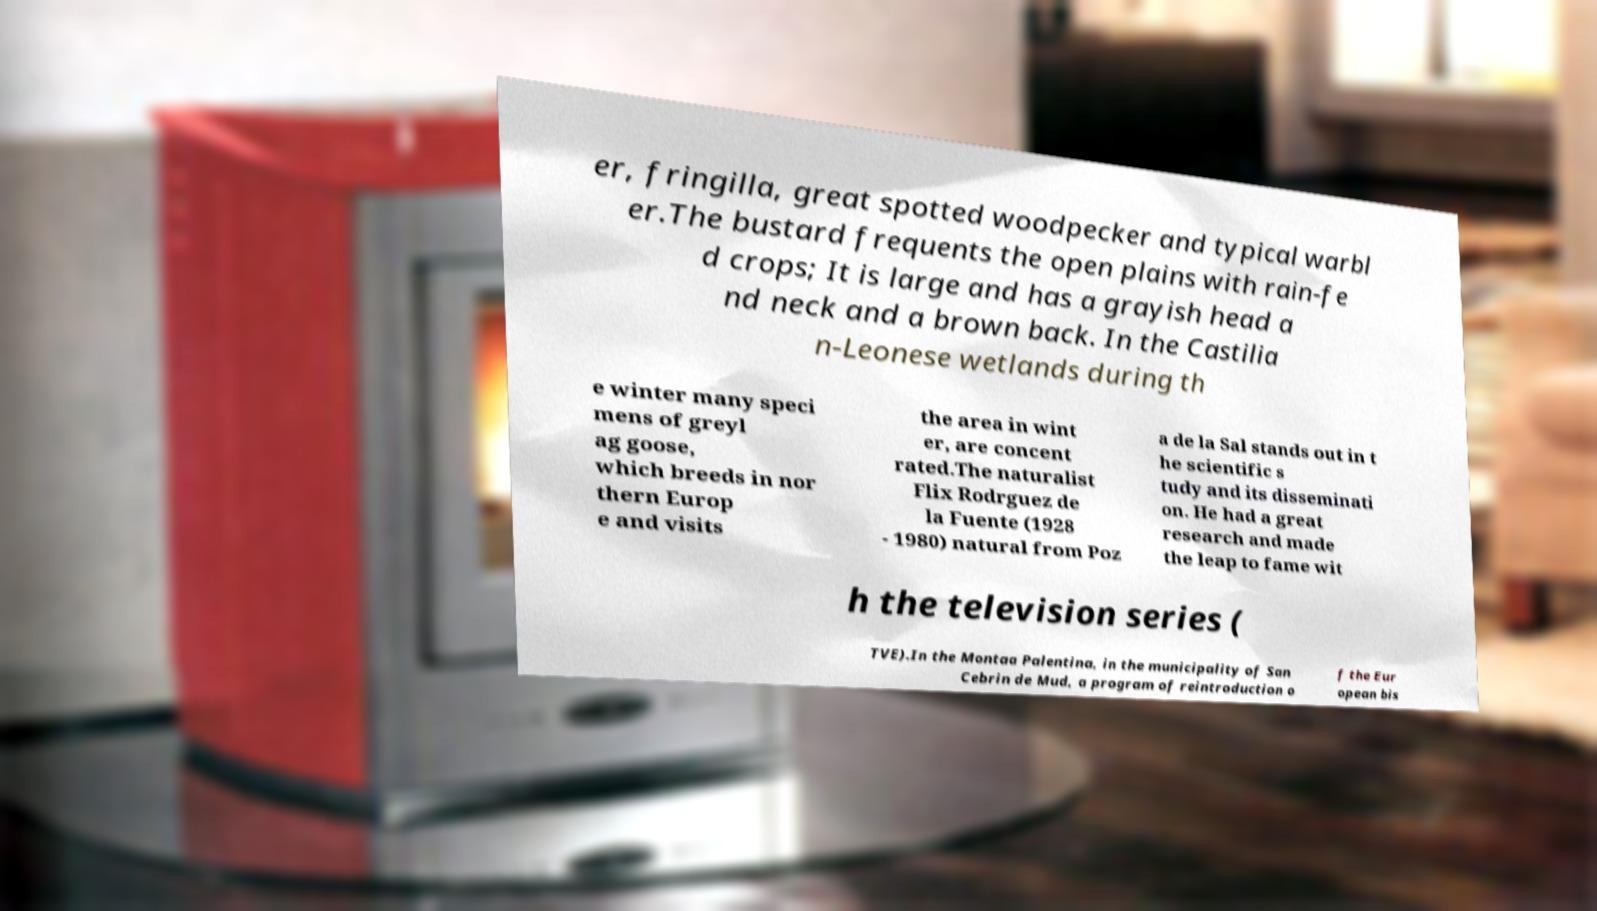Can you read and provide the text displayed in the image?This photo seems to have some interesting text. Can you extract and type it out for me? er, fringilla, great spotted woodpecker and typical warbl er.The bustard frequents the open plains with rain-fe d crops; It is large and has a grayish head a nd neck and a brown back. In the Castilia n-Leonese wetlands during th e winter many speci mens of greyl ag goose, which breeds in nor thern Europ e and visits the area in wint er, are concent rated.The naturalist Flix Rodrguez de la Fuente (1928 - 1980) natural from Poz a de la Sal stands out in t he scientific s tudy and its disseminati on. He had a great research and made the leap to fame wit h the television series ( TVE).In the Montaa Palentina, in the municipality of San Cebrin de Mud, a program of reintroduction o f the Eur opean bis 